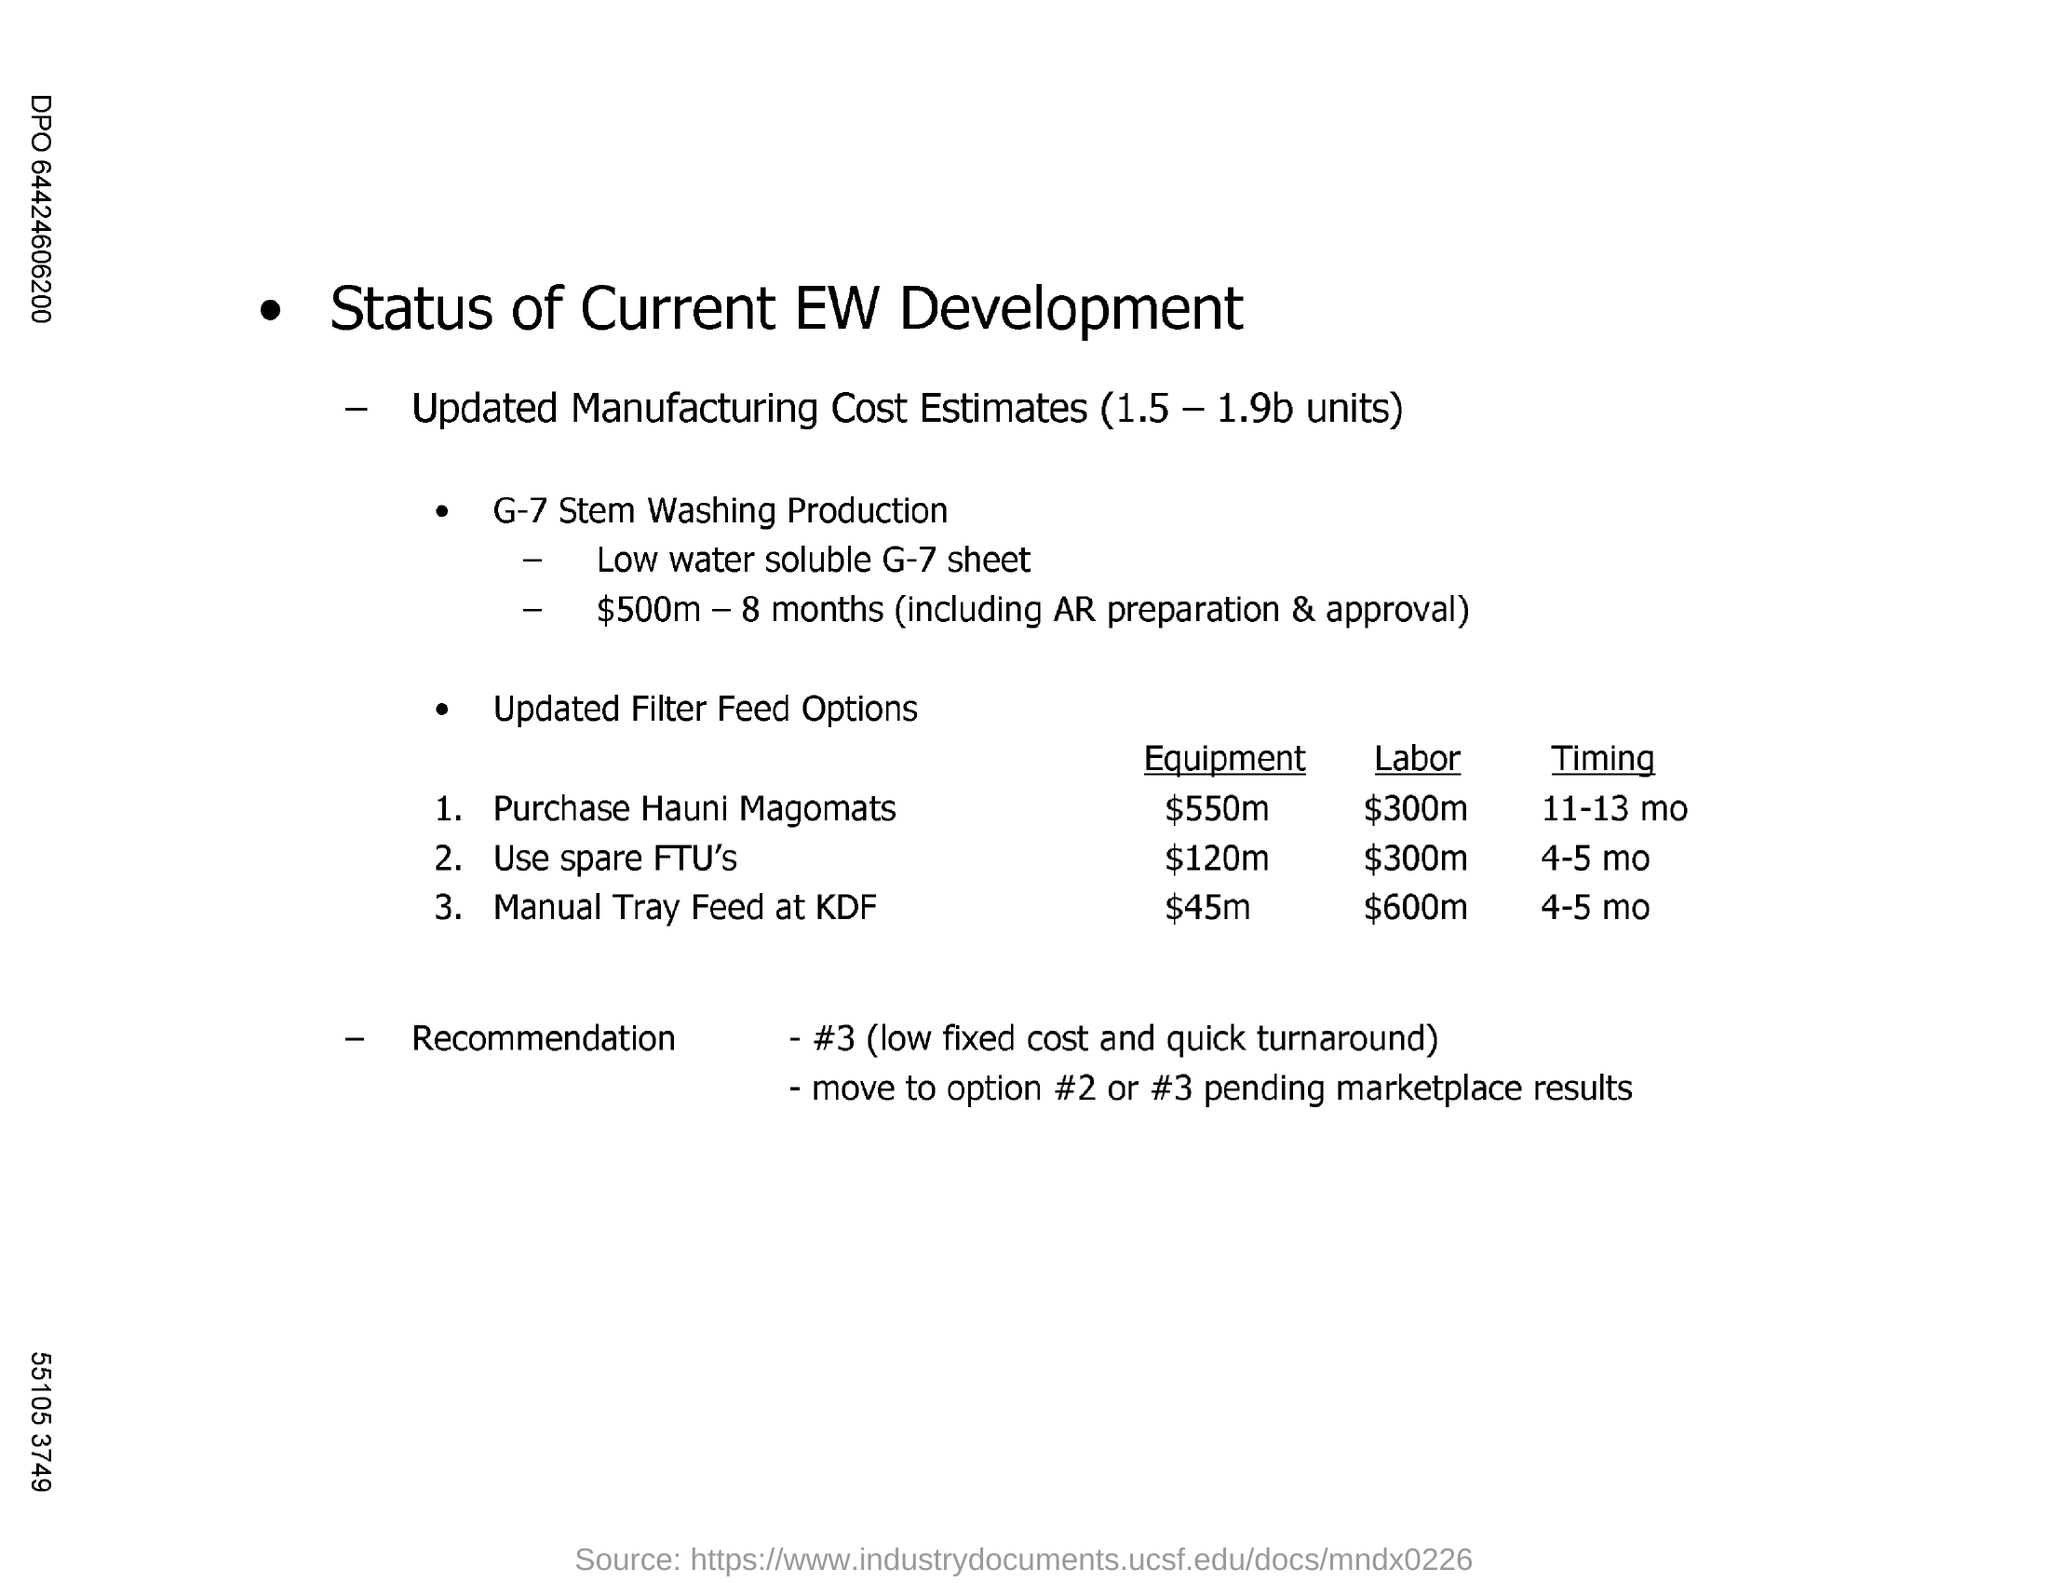Indicate a few pertinent items in this graphic. The manual tray feed at KDF has the highest labor charge among the filter feed options. The timing of Purchase Hauni Magomats is typically between 11-13 months. 